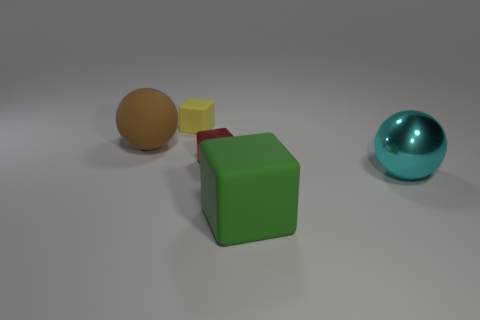Can you describe the positions of the objects in relation to each other? Certainly! The image depicts four objects positioned on a flat surface. Starting from the left, there is a large brown matte sphere. Next to it, towards the center, we see a small stack composed of a red matte cube topped by a smaller yellow matte cube. On the far right, slightly separated from the others, is a shiny cyan metallic sphere. The arrangement creates a visually interesting sequence of shapes and colors. 